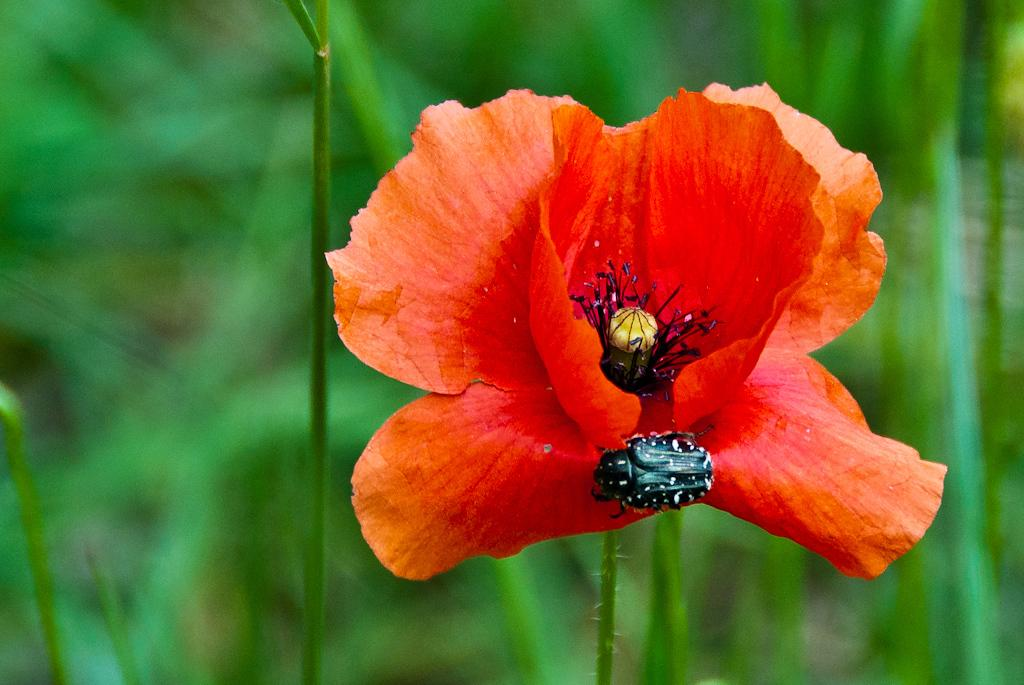What type of flower can be seen in the image? There is a red color flower in the image. What other living organism is present in the image? There is a black color insect in the image. What can be seen in the background of the image? There are plants in the background of the image. How many goldfish are swimming in the image? There are no goldfish present in the image. What type of hands can be seen holding the flower in the image? There are no hands visible in the image; only the flower and insect are present. 